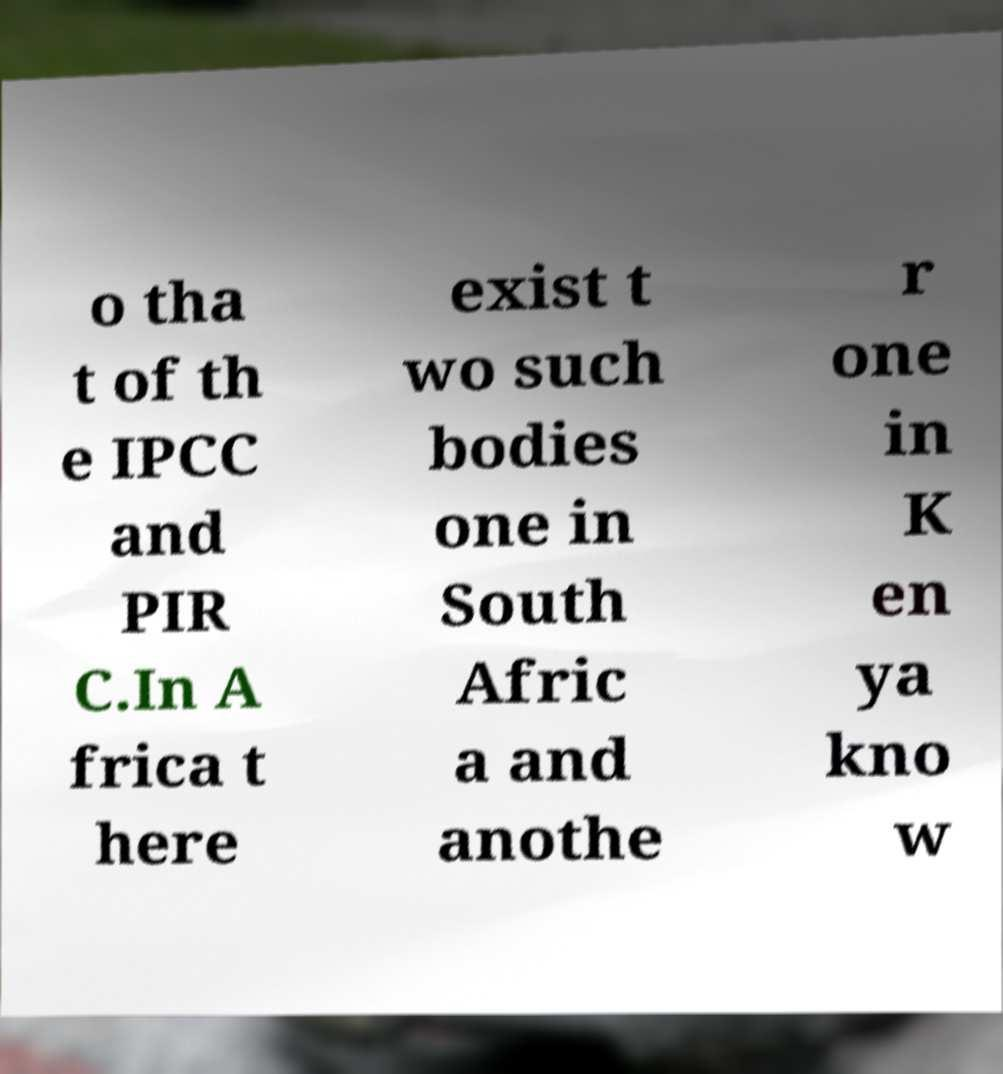Could you assist in decoding the text presented in this image and type it out clearly? o tha t of th e IPCC and PIR C.In A frica t here exist t wo such bodies one in South Afric a and anothe r one in K en ya kno w 